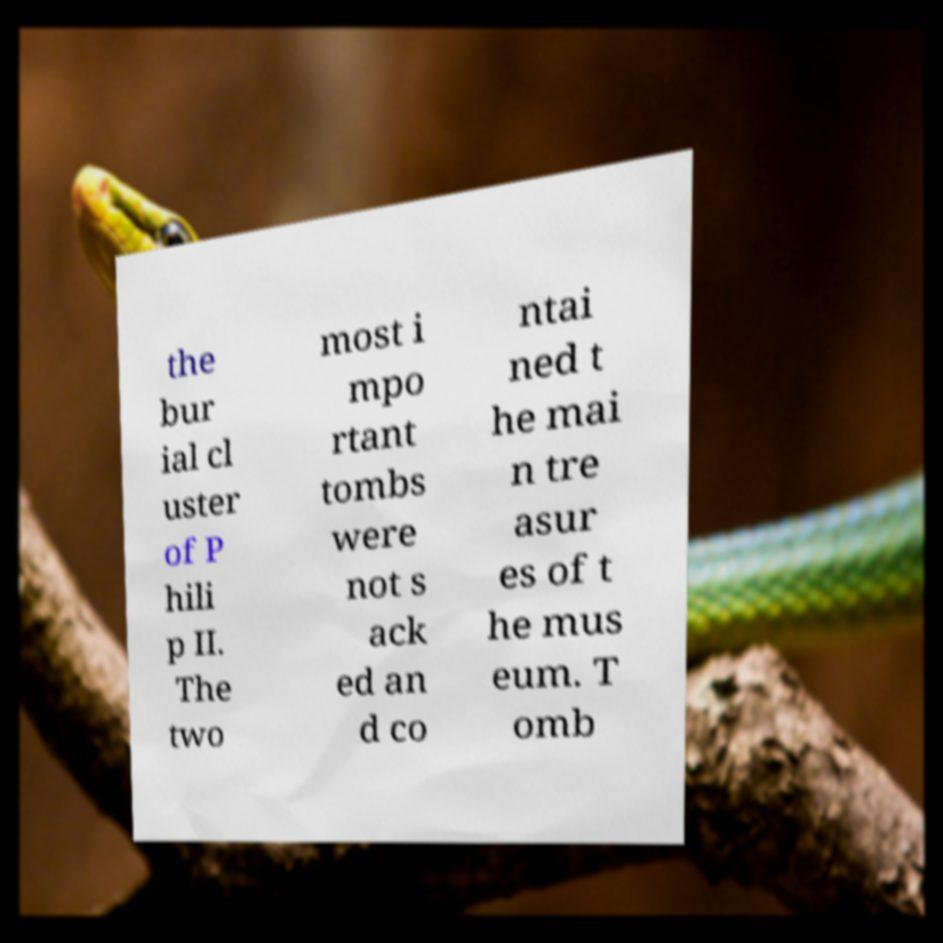Can you read and provide the text displayed in the image?This photo seems to have some interesting text. Can you extract and type it out for me? the bur ial cl uster of P hili p II. The two most i mpo rtant tombs were not s ack ed an d co ntai ned t he mai n tre asur es of t he mus eum. T omb 